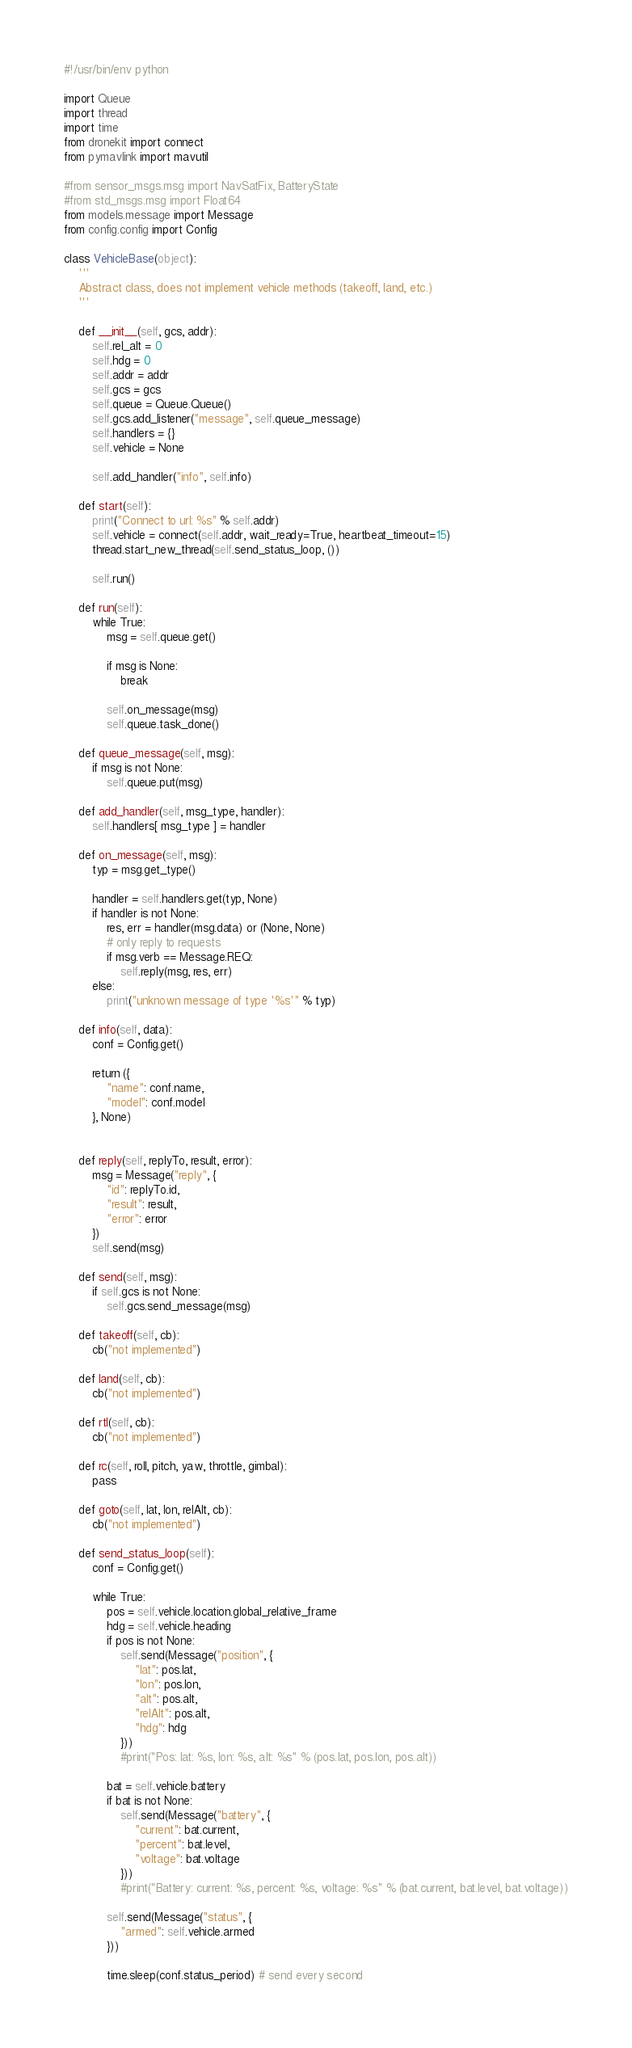Convert code to text. <code><loc_0><loc_0><loc_500><loc_500><_Python_>#!/usr/bin/env python

import Queue
import thread
import time
from dronekit import connect
from pymavlink import mavutil

#from sensor_msgs.msg import NavSatFix, BatteryState
#from std_msgs.msg import Float64
from models.message import Message
from config.config import Config

class VehicleBase(object):
    '''
    Abstract class, does not implement vehicle methods (takeoff, land, etc.)
    '''

    def __init__(self, gcs, addr):
        self.rel_alt = 0
        self.hdg = 0
        self.addr = addr
        self.gcs = gcs
        self.queue = Queue.Queue()
        self.gcs.add_listener("message", self.queue_message)
        self.handlers = {}
        self.vehicle = None

        self.add_handler("info", self.info)

    def start(self):
        print("Connect to url: %s" % self.addr)
        self.vehicle = connect(self.addr, wait_ready=True, heartbeat_timeout=15)
        thread.start_new_thread(self.send_status_loop, ())

        self.run()

    def run(self):
        while True:
            msg = self.queue.get()

            if msg is None:
                break

            self.on_message(msg)
            self.queue.task_done()

    def queue_message(self, msg):
        if msg is not None:
            self.queue.put(msg)

    def add_handler(self, msg_type, handler):
        self.handlers[ msg_type ] = handler

    def on_message(self, msg):
        typ = msg.get_type()

        handler = self.handlers.get(typ, None)
        if handler is not None:
            res, err = handler(msg.data) or (None, None)
            # only reply to requests
            if msg.verb == Message.REQ:
                self.reply(msg, res, err)
        else:
            print("unknown message of type '%s'" % typ)

    def info(self, data):
        conf = Config.get()

        return ({
            "name": conf.name,
            "model": conf.model
        }, None)


    def reply(self, replyTo, result, error):
        msg = Message("reply", {
            "id": replyTo.id,
            "result": result,
            "error": error
        })
        self.send(msg)

    def send(self, msg):
        if self.gcs is not None:
            self.gcs.send_message(msg)

    def takeoff(self, cb):
        cb("not implemented")

    def land(self, cb):
        cb("not implemented")

    def rtl(self, cb):
        cb("not implemented")

    def rc(self, roll, pitch, yaw, throttle, gimbal):
        pass

    def goto(self, lat, lon, relAlt, cb):
        cb("not implemented")

    def send_status_loop(self):
        conf = Config.get()

        while True:
            pos = self.vehicle.location.global_relative_frame
            hdg = self.vehicle.heading
            if pos is not None:
                self.send(Message("position", {
                    "lat": pos.lat,
                    "lon": pos.lon,
                    "alt": pos.alt,
                    "relAlt": pos.alt,
                    "hdg": hdg
                }))
                #print("Pos: lat: %s, lon: %s, alt: %s" % (pos.lat, pos.lon, pos.alt))

            bat = self.vehicle.battery
            if bat is not None:
                self.send(Message("battery", {
                    "current": bat.current,
                    "percent": bat.level,
                    "voltage": bat.voltage
                }))
                #print("Battery: current: %s, percent: %s, voltage: %s" % (bat.current, bat.level, bat.voltage))

            self.send(Message("status", {
                "armed": self.vehicle.armed
            }))

            time.sleep(conf.status_period) # send every second



</code> 